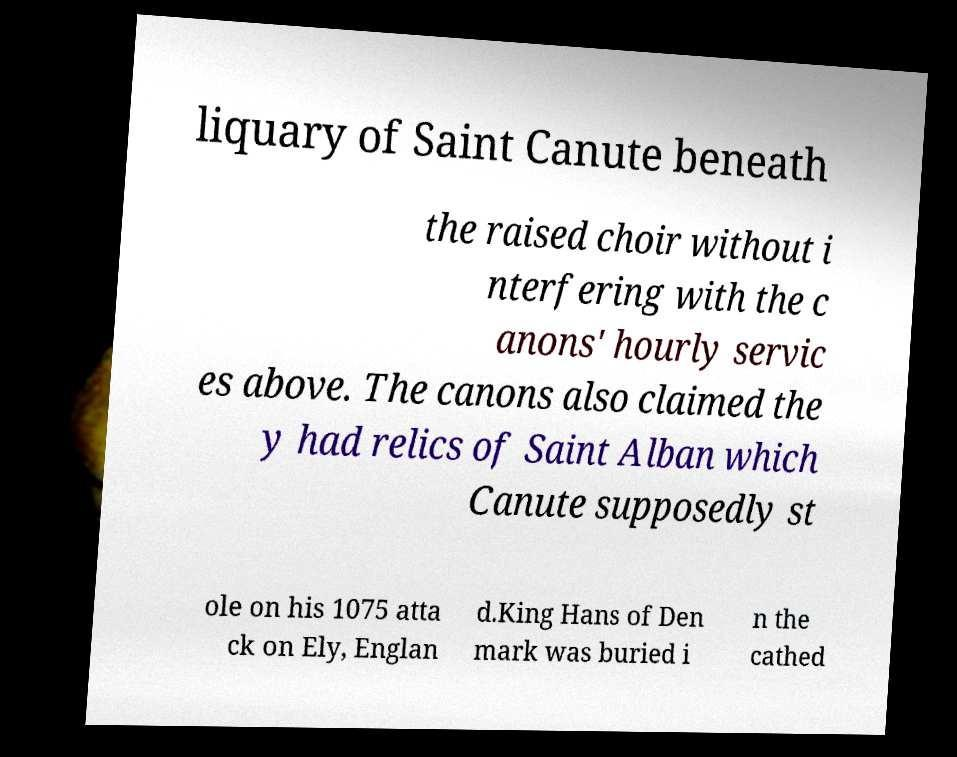Can you read and provide the text displayed in the image?This photo seems to have some interesting text. Can you extract and type it out for me? liquary of Saint Canute beneath the raised choir without i nterfering with the c anons' hourly servic es above. The canons also claimed the y had relics of Saint Alban which Canute supposedly st ole on his 1075 atta ck on Ely, Englan d.King Hans of Den mark was buried i n the cathed 